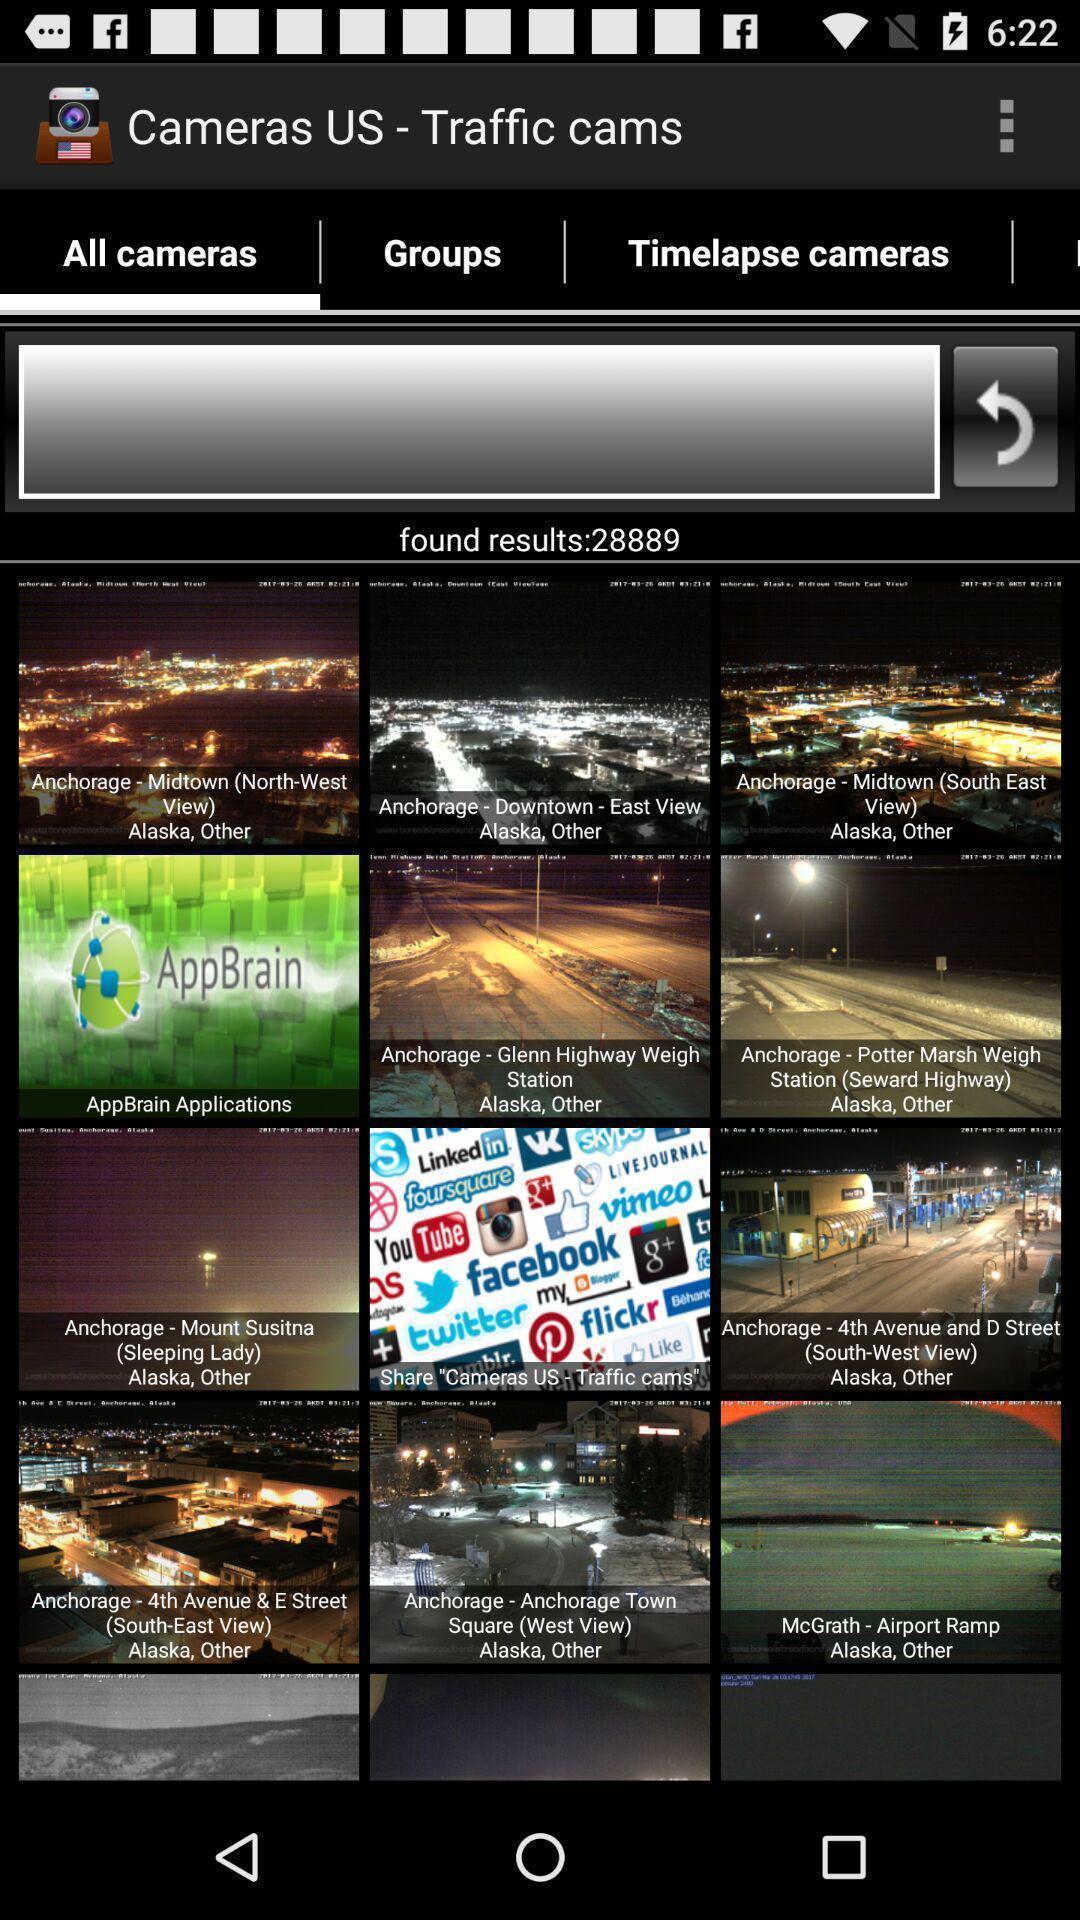Tell me about the visual elements in this screen capture. Welcome page of a surveillance app. 